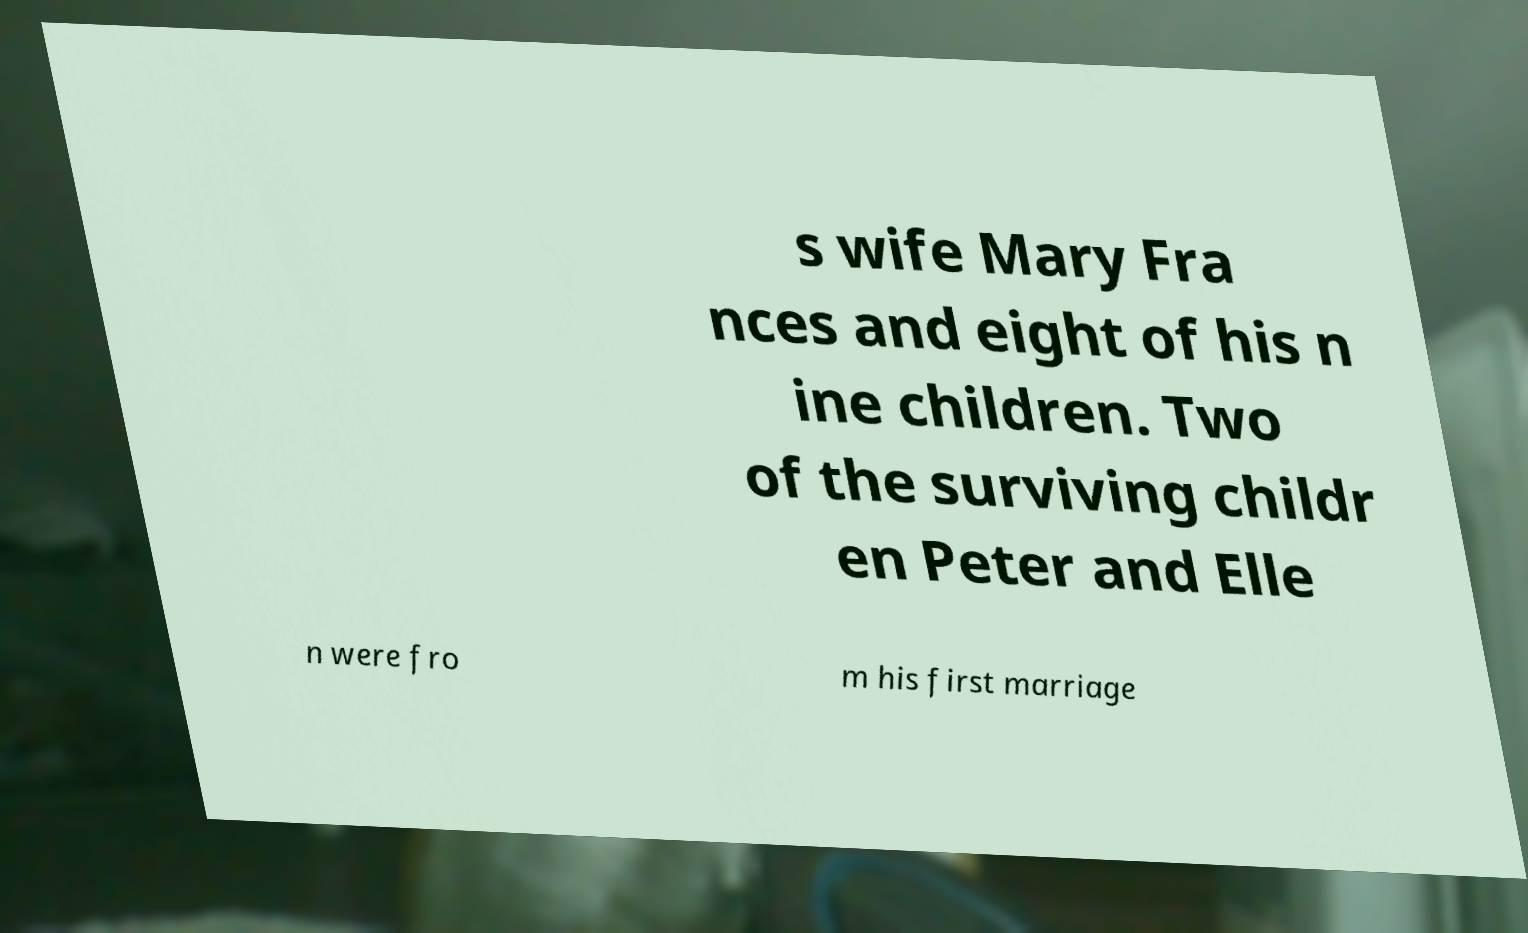Could you assist in decoding the text presented in this image and type it out clearly? s wife Mary Fra nces and eight of his n ine children. Two of the surviving childr en Peter and Elle n were fro m his first marriage 